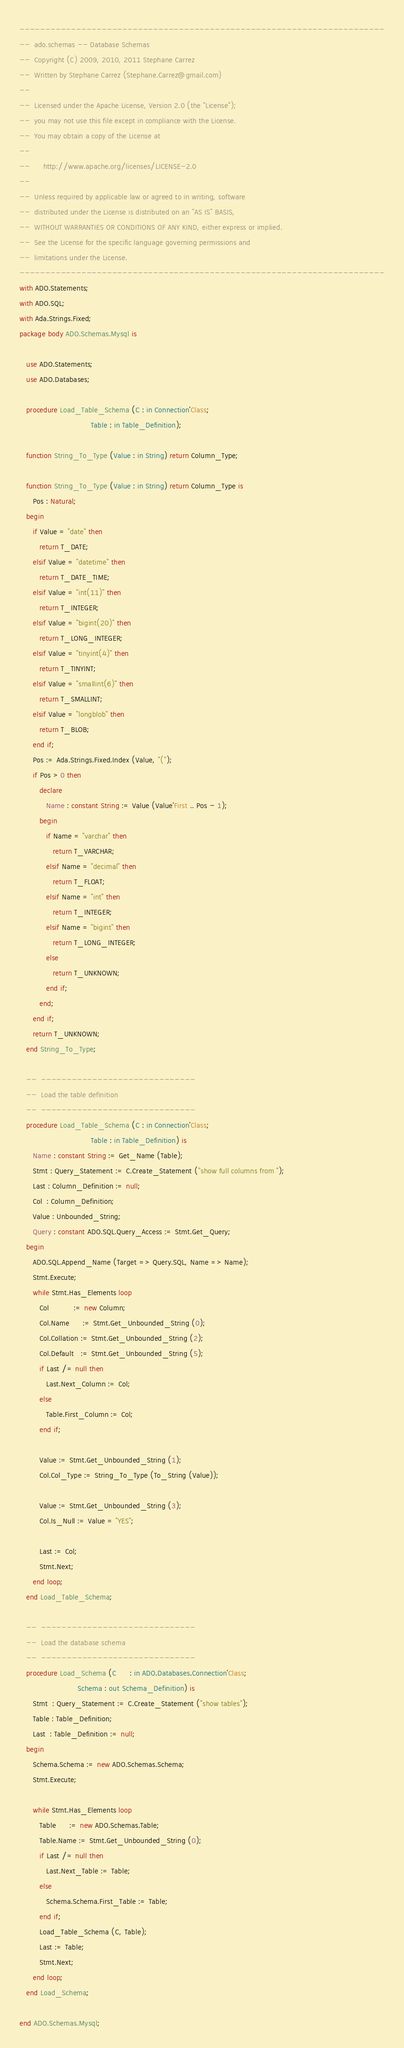Convert code to text. <code><loc_0><loc_0><loc_500><loc_500><_Ada_>-----------------------------------------------------------------------
--  ado.schemas -- Database Schemas
--  Copyright (C) 2009, 2010, 2011 Stephane Carrez
--  Written by Stephane Carrez (Stephane.Carrez@gmail.com)
--
--  Licensed under the Apache License, Version 2.0 (the "License");
--  you may not use this file except in compliance with the License.
--  You may obtain a copy of the License at
--
--      http://www.apache.org/licenses/LICENSE-2.0
--
--  Unless required by applicable law or agreed to in writing, software
--  distributed under the License is distributed on an "AS IS" BASIS,
--  WITHOUT WARRANTIES OR CONDITIONS OF ANY KIND, either express or implied.
--  See the License for the specific language governing permissions and
--  limitations under the License.
-----------------------------------------------------------------------
with ADO.Statements;
with ADO.SQL;
with Ada.Strings.Fixed;
package body ADO.Schemas.Mysql is

   use ADO.Statements;
   use ADO.Databases;

   procedure Load_Table_Schema (C : in Connection'Class;
                                Table : in Table_Definition);

   function String_To_Type (Value : in String) return Column_Type;

   function String_To_Type (Value : in String) return Column_Type is
      Pos : Natural;
   begin
      if Value = "date" then
         return T_DATE;
      elsif Value = "datetime" then
         return T_DATE_TIME;
      elsif Value = "int(11)" then
         return T_INTEGER;
      elsif Value = "bigint(20)" then
         return T_LONG_INTEGER;
      elsif Value = "tinyint(4)" then
         return T_TINYINT;
      elsif Value = "smallint(6)" then
         return T_SMALLINT;
      elsif Value = "longblob" then
         return T_BLOB;
      end if;
      Pos := Ada.Strings.Fixed.Index (Value, "(");
      if Pos > 0 then
         declare
            Name : constant String := Value (Value'First .. Pos - 1);
         begin
            if Name = "varchar" then
               return T_VARCHAR;
            elsif Name = "decimal" then
               return T_FLOAT;
            elsif Name = "int" then
               return T_INTEGER;
            elsif Name = "bigint" then
               return T_LONG_INTEGER;
            else
               return T_UNKNOWN;
            end if;
         end;
      end if;
      return T_UNKNOWN;
   end String_To_Type;

   --  ------------------------------
   --  Load the table definition
   --  ------------------------------
   procedure Load_Table_Schema (C : in Connection'Class;
                                Table : in Table_Definition) is
      Name : constant String := Get_Name (Table);
      Stmt : Query_Statement := C.Create_Statement ("show full columns from ");
      Last : Column_Definition := null;
      Col  : Column_Definition;
      Value : Unbounded_String;
      Query : constant ADO.SQL.Query_Access := Stmt.Get_Query;
   begin
      ADO.SQL.Append_Name (Target => Query.SQL, Name => Name);
      Stmt.Execute;
      while Stmt.Has_Elements loop
         Col           := new Column;
         Col.Name      := Stmt.Get_Unbounded_String (0);
         Col.Collation := Stmt.Get_Unbounded_String (2);
         Col.Default   := Stmt.Get_Unbounded_String (5);
         if Last /= null then
            Last.Next_Column := Col;
         else
            Table.First_Column := Col;
         end if;

         Value := Stmt.Get_Unbounded_String (1);
         Col.Col_Type := String_To_Type (To_String (Value));

         Value := Stmt.Get_Unbounded_String (3);
         Col.Is_Null := Value = "YES";

         Last := Col;
         Stmt.Next;
      end loop;
   end Load_Table_Schema;

   --  ------------------------------
   --  Load the database schema
   --  ------------------------------
   procedure Load_Schema (C      : in ADO.Databases.Connection'Class;
                          Schema : out Schema_Definition) is
      Stmt  : Query_Statement := C.Create_Statement ("show tables");
      Table : Table_Definition;
      Last  : Table_Definition := null;
   begin
      Schema.Schema := new ADO.Schemas.Schema;
      Stmt.Execute;

      while Stmt.Has_Elements loop
         Table      := new ADO.Schemas.Table;
         Table.Name := Stmt.Get_Unbounded_String (0);
         if Last /= null then
            Last.Next_Table := Table;
         else
            Schema.Schema.First_Table := Table;
         end if;
         Load_Table_Schema (C, Table);
         Last := Table;
         Stmt.Next;
      end loop;
   end Load_Schema;

end ADO.Schemas.Mysql;
</code> 